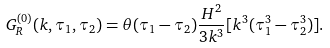<formula> <loc_0><loc_0><loc_500><loc_500>G _ { R } ^ { ( 0 ) } ( k , \tau _ { 1 } , \tau _ { 2 } ) = \theta ( \tau _ { 1 } - \tau _ { 2 } ) \frac { H ^ { 2 } } { 3 k ^ { 3 } } [ k ^ { 3 } ( \tau _ { 1 } ^ { 3 } - \tau _ { 2 } ^ { 3 } ) ] .</formula> 